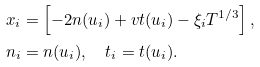Convert formula to latex. <formula><loc_0><loc_0><loc_500><loc_500>x _ { i } & = \left [ - 2 n ( u _ { i } ) + v t ( u _ { i } ) - \xi _ { i } T ^ { 1 / 3 } \right ] , \\ n _ { i } & = n ( u _ { i } ) , \quad t _ { i } = t ( u _ { i } ) .</formula> 